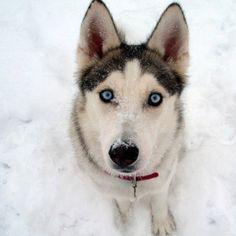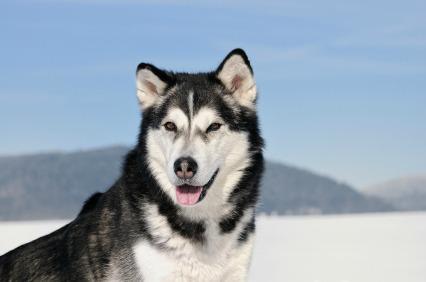The first image is the image on the left, the second image is the image on the right. For the images displayed, is the sentence "There are exactly two dogs posing in a snowy environment." factually correct? Answer yes or no. Yes. 